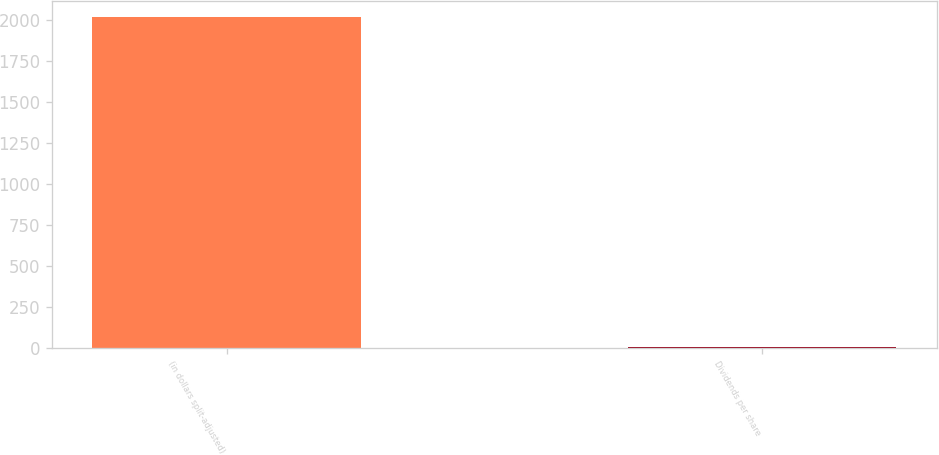Convert chart to OTSL. <chart><loc_0><loc_0><loc_500><loc_500><bar_chart><fcel>(in dollars split-adjusted)<fcel>Dividends per share<nl><fcel>2019<fcel>2.9<nl></chart> 